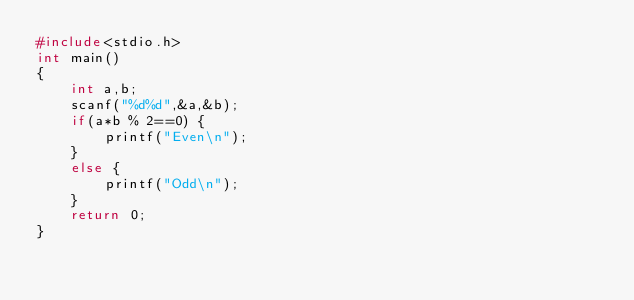<code> <loc_0><loc_0><loc_500><loc_500><_C_>#include<stdio.h>
int main()
{
    int a,b;
    scanf("%d%d",&a,&b);
    if(a*b % 2==0) {
        printf("Even\n");
    }
    else {
        printf("Odd\n");
    }
    return 0;
}
</code> 